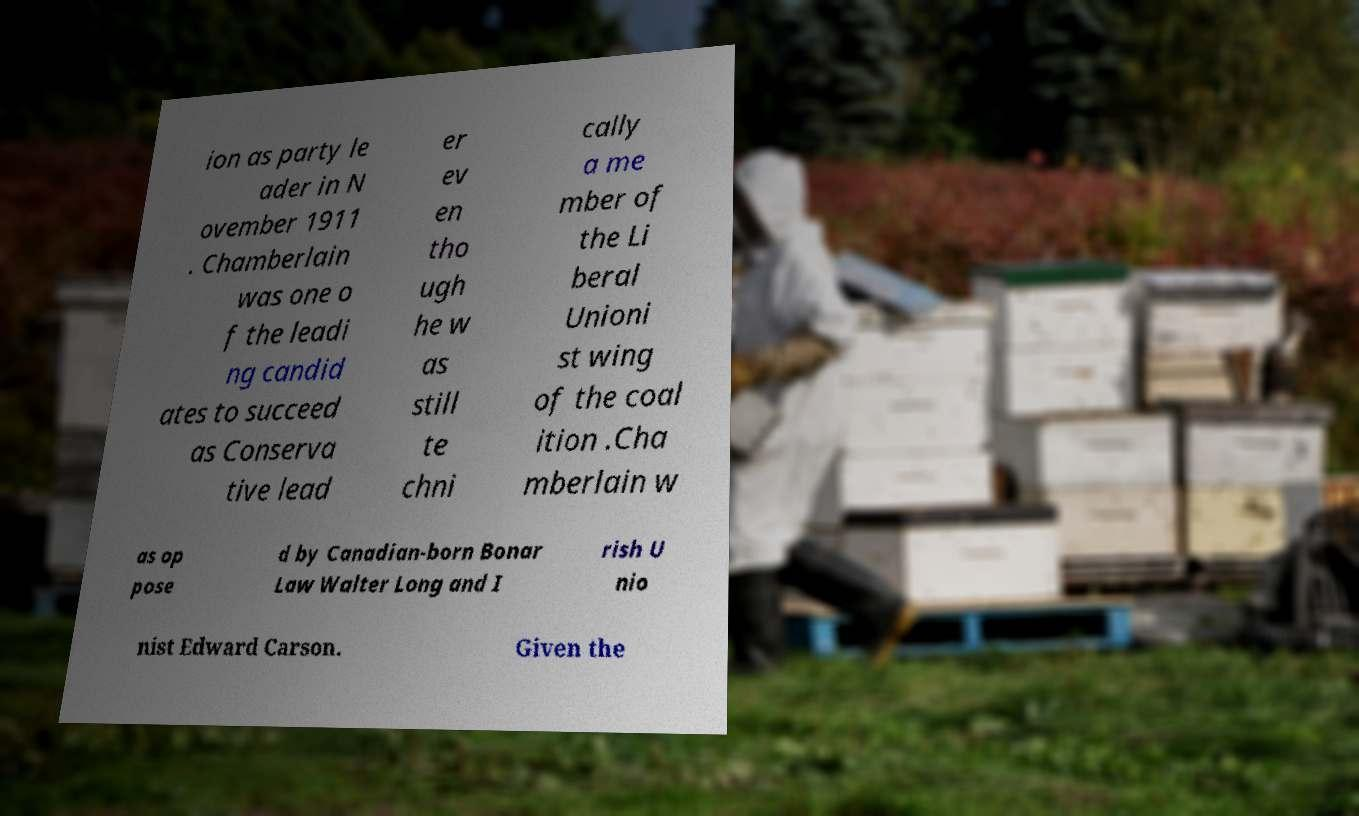Please read and relay the text visible in this image. What does it say? ion as party le ader in N ovember 1911 . Chamberlain was one o f the leadi ng candid ates to succeed as Conserva tive lead er ev en tho ugh he w as still te chni cally a me mber of the Li beral Unioni st wing of the coal ition .Cha mberlain w as op pose d by Canadian-born Bonar Law Walter Long and I rish U nio nist Edward Carson. Given the 